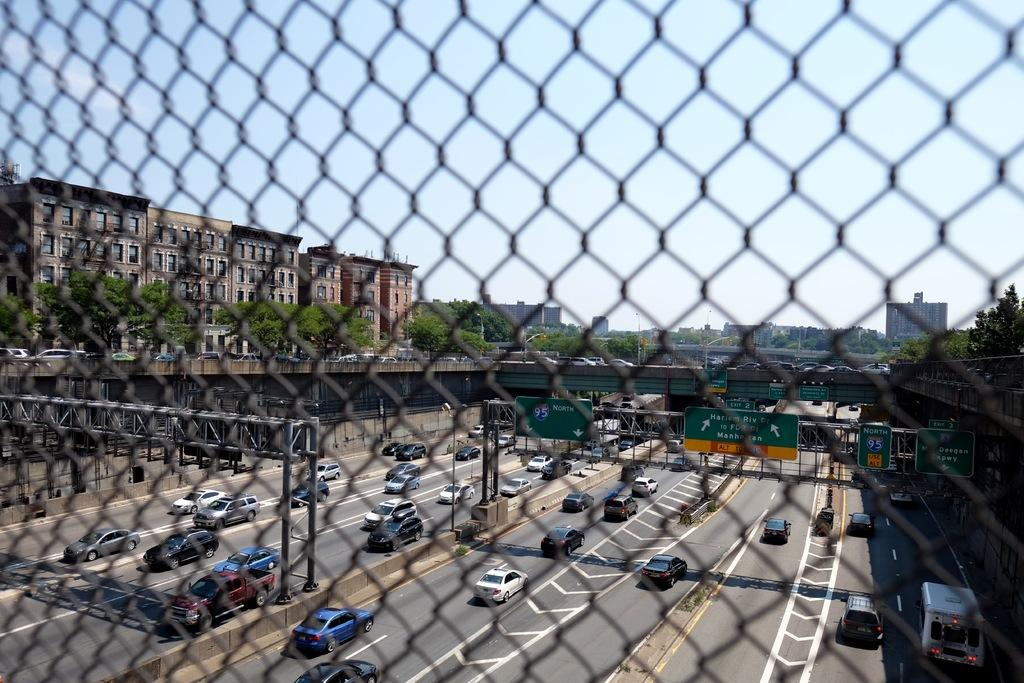What type of vehicles can be seen on the road in the image? There are cars on the road in the image. What else is present in the image besides the cars? There are boards with text, trees, buildings, and a metal fence in the image. What is the condition of the sky in the image? The sky is cloudy in the image. What type of food is being served in the vase in the image? There is no vase or food present in the image. Can you describe the beetle that is crawling on the metal fence in the image? There is no beetle present in the image; only the metal fence is mentioned. 